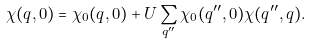Convert formula to latex. <formula><loc_0><loc_0><loc_500><loc_500>\chi ( { q } , 0 ) = \chi _ { 0 } ( { q } , 0 ) + U \sum _ { q ^ { \prime \prime } } \chi _ { 0 } ( { q ^ { \prime \prime } } , 0 ) \chi ( { q ^ { \prime \prime } } , { q } ) .</formula> 